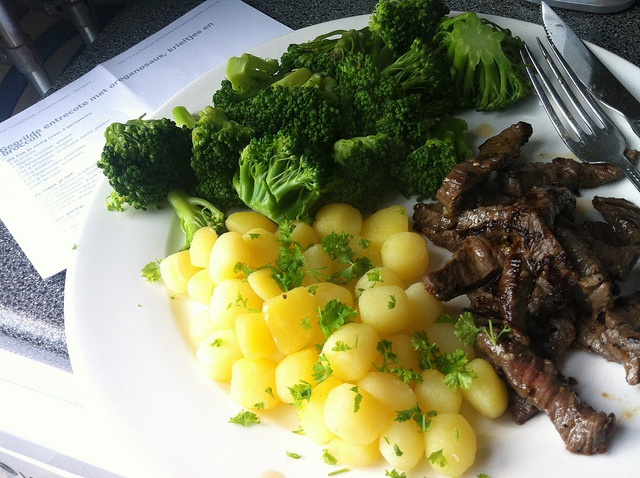Describe the objects in this image and their specific colors. I can see broccoli in black, darkgreen, and olive tones, broccoli in black, darkgreen, and olive tones, broccoli in black, darkgreen, and olive tones, broccoli in black and darkgreen tones, and broccoli in black, darkgreen, and olive tones in this image. 